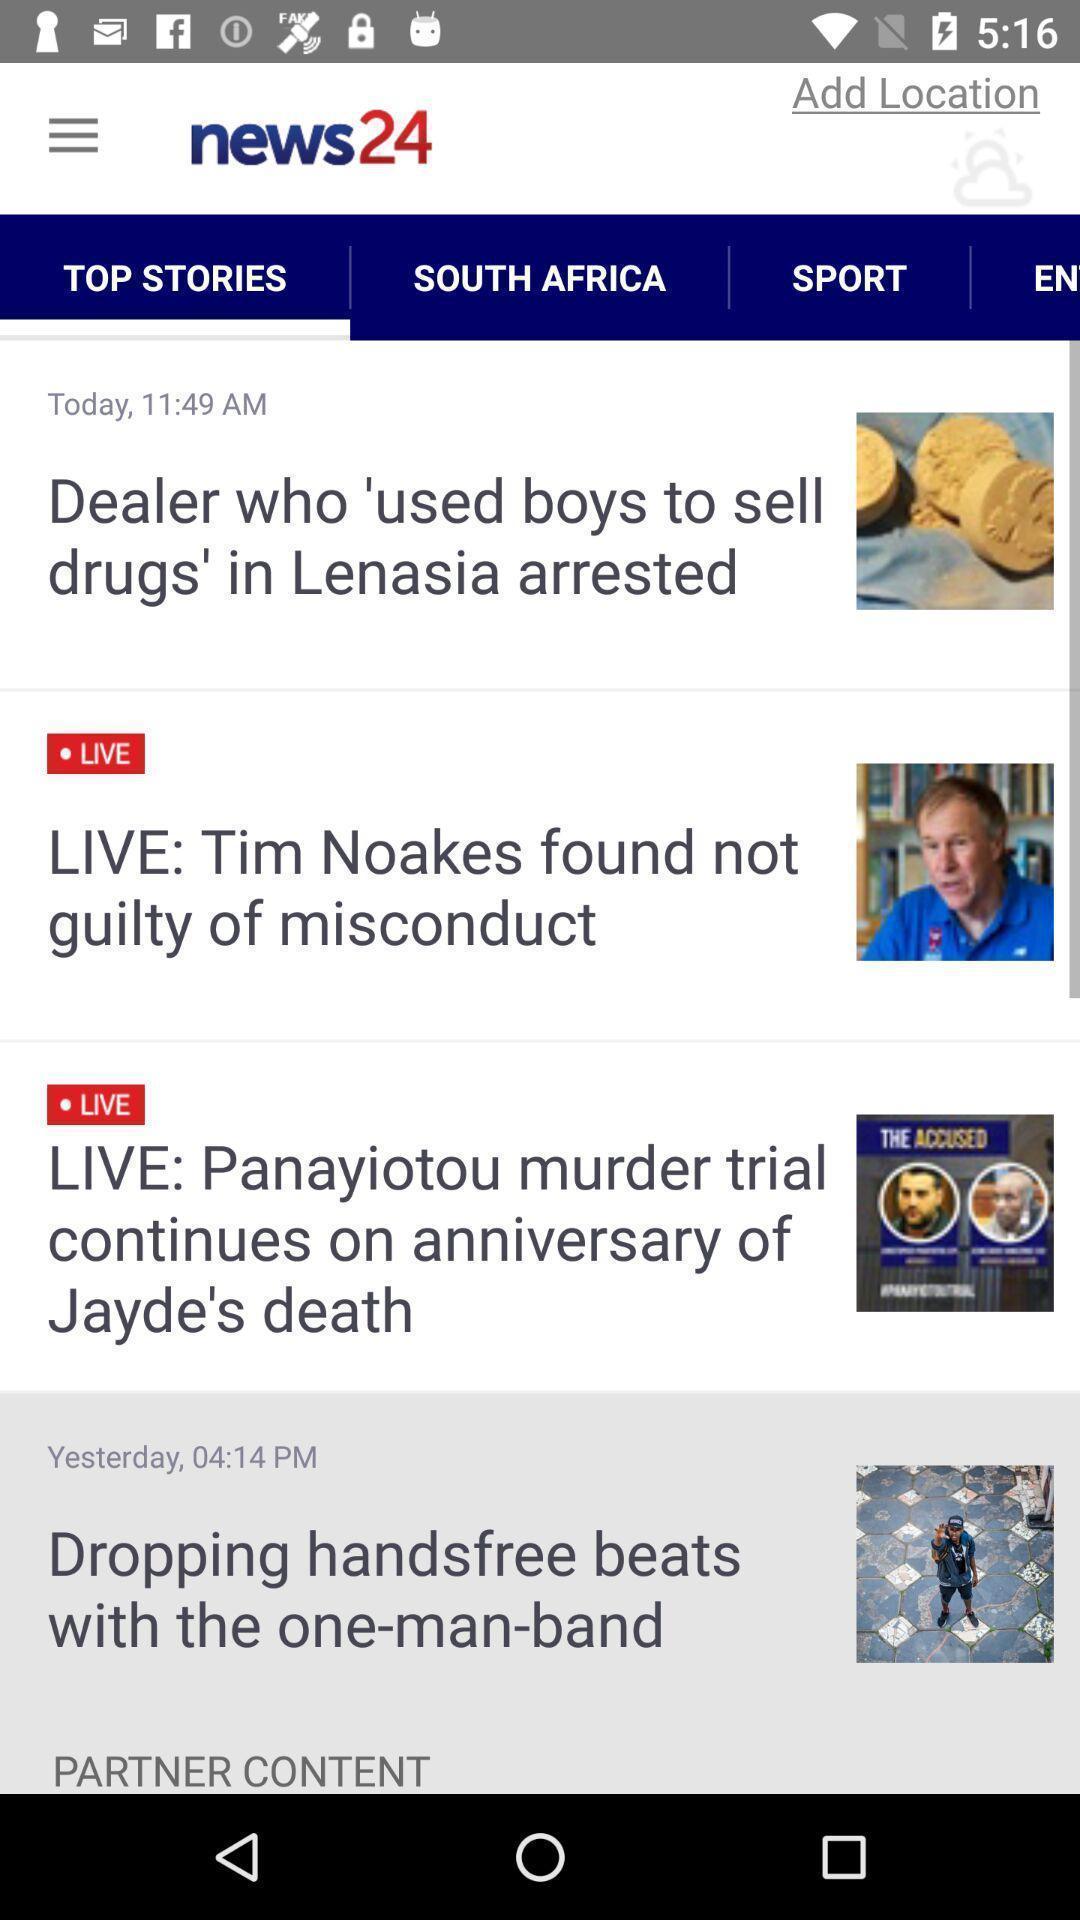Give me a narrative description of this picture. Various article displayed in news app. 